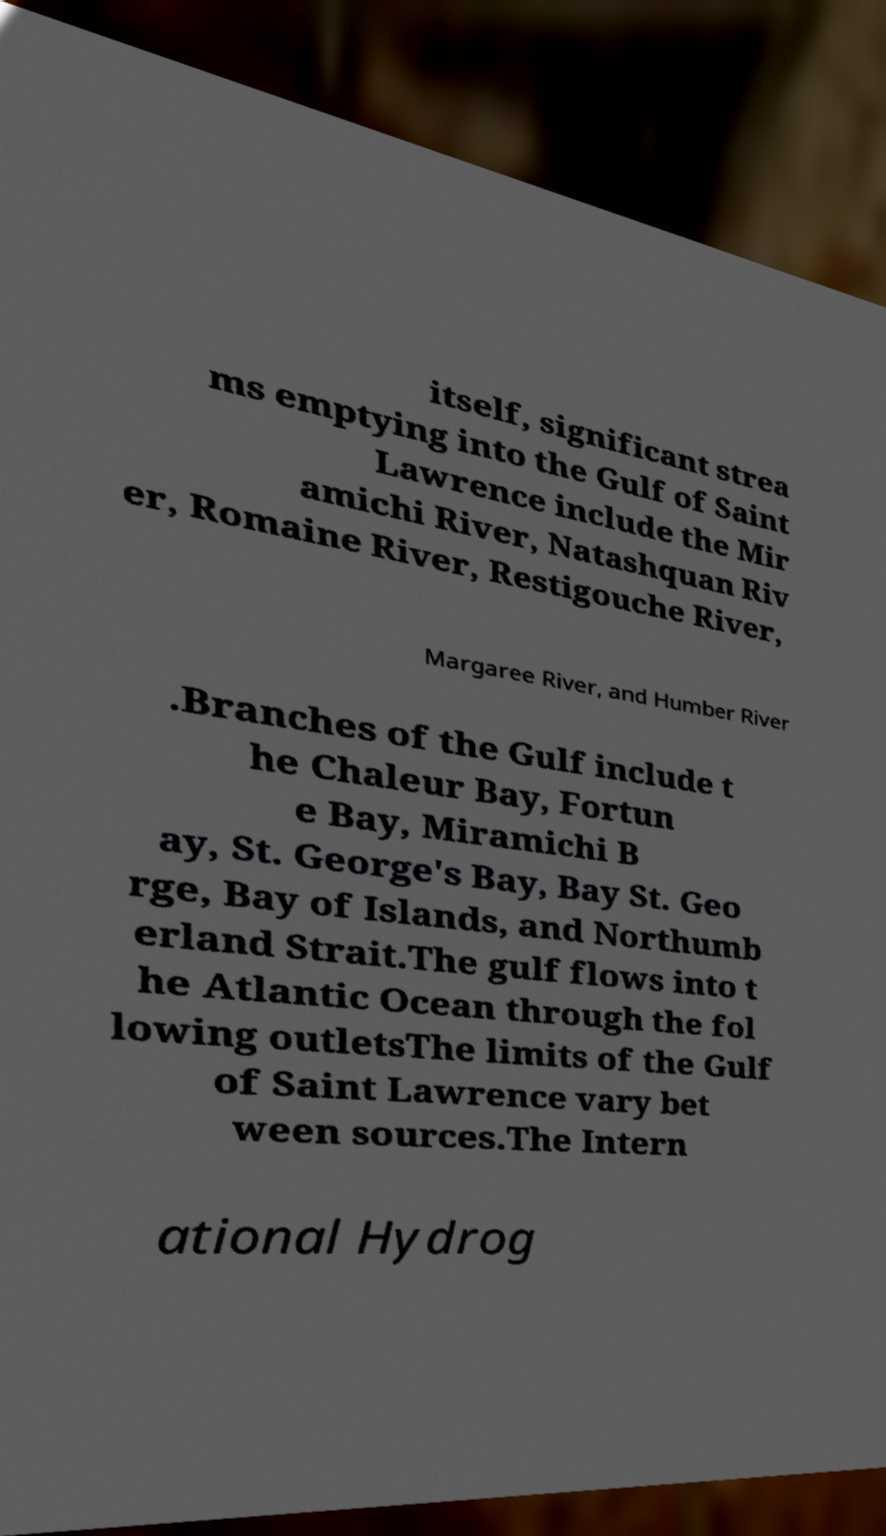What messages or text are displayed in this image? I need them in a readable, typed format. itself, significant strea ms emptying into the Gulf of Saint Lawrence include the Mir amichi River, Natashquan Riv er, Romaine River, Restigouche River, Margaree River, and Humber River .Branches of the Gulf include t he Chaleur Bay, Fortun e Bay, Miramichi B ay, St. George's Bay, Bay St. Geo rge, Bay of Islands, and Northumb erland Strait.The gulf flows into t he Atlantic Ocean through the fol lowing outletsThe limits of the Gulf of Saint Lawrence vary bet ween sources.The Intern ational Hydrog 